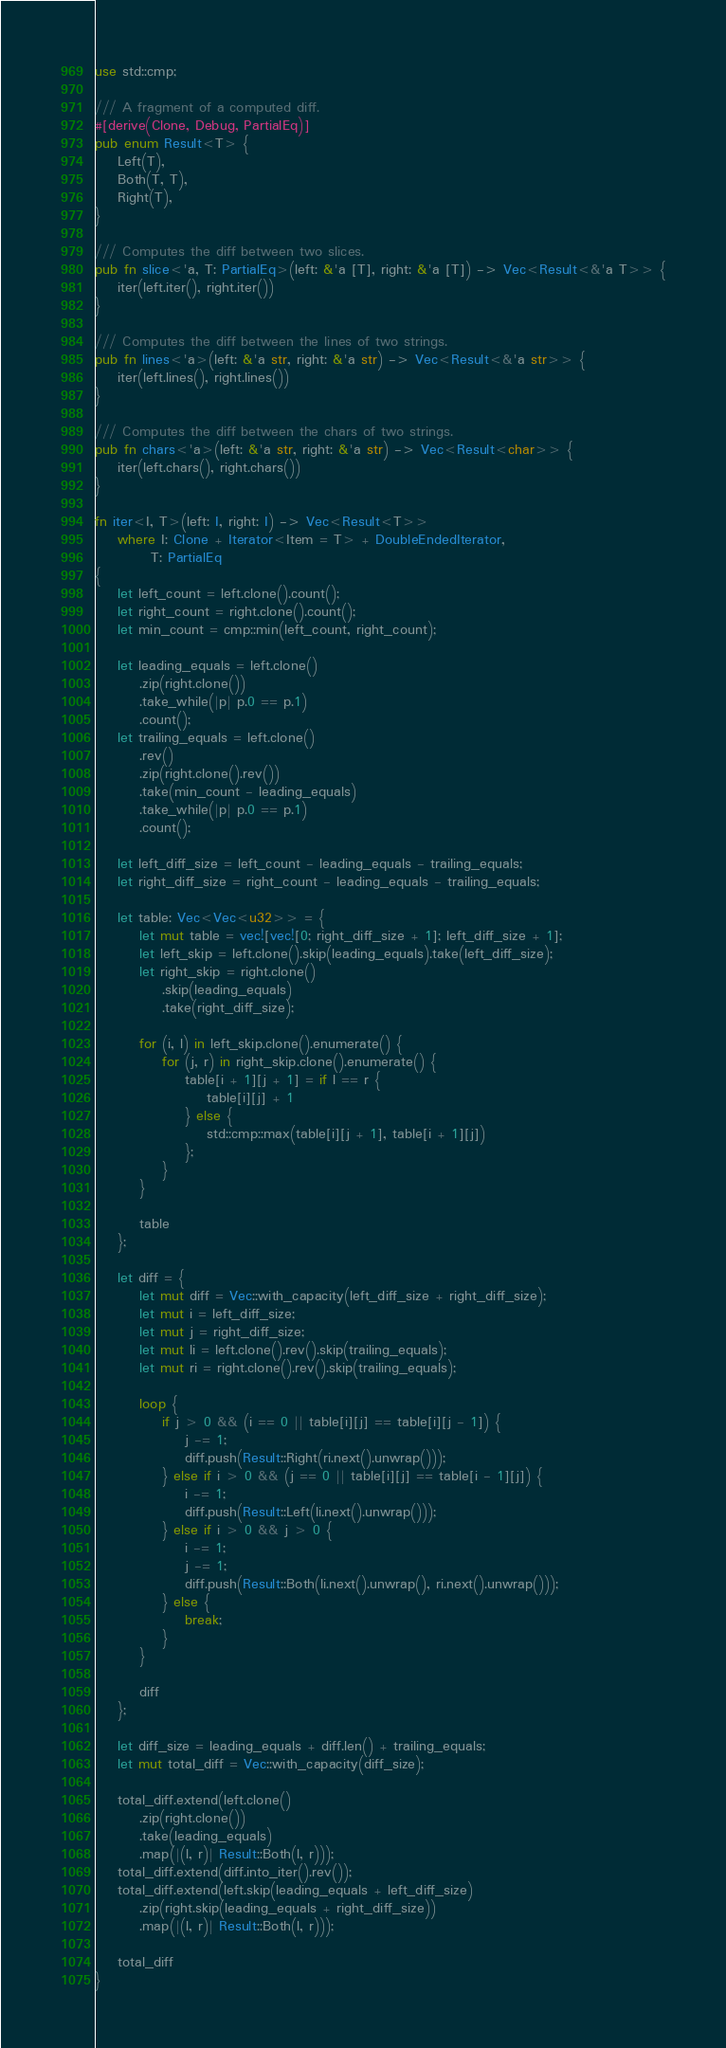Convert code to text. <code><loc_0><loc_0><loc_500><loc_500><_Rust_>use std::cmp;

/// A fragment of a computed diff.
#[derive(Clone, Debug, PartialEq)]
pub enum Result<T> {
    Left(T),
    Both(T, T),
    Right(T),
}

/// Computes the diff between two slices.
pub fn slice<'a, T: PartialEq>(left: &'a [T], right: &'a [T]) -> Vec<Result<&'a T>> {
    iter(left.iter(), right.iter())
}

/// Computes the diff between the lines of two strings.
pub fn lines<'a>(left: &'a str, right: &'a str) -> Vec<Result<&'a str>> {
    iter(left.lines(), right.lines())
}

/// Computes the diff between the chars of two strings.
pub fn chars<'a>(left: &'a str, right: &'a str) -> Vec<Result<char>> {
    iter(left.chars(), right.chars())
}

fn iter<I, T>(left: I, right: I) -> Vec<Result<T>>
    where I: Clone + Iterator<Item = T> + DoubleEndedIterator,
          T: PartialEq
{
    let left_count = left.clone().count();
    let right_count = right.clone().count();
    let min_count = cmp::min(left_count, right_count);

    let leading_equals = left.clone()
        .zip(right.clone())
        .take_while(|p| p.0 == p.1)
        .count();
    let trailing_equals = left.clone()
        .rev()
        .zip(right.clone().rev())
        .take(min_count - leading_equals)
        .take_while(|p| p.0 == p.1)
        .count();

    let left_diff_size = left_count - leading_equals - trailing_equals;
    let right_diff_size = right_count - leading_equals - trailing_equals;

    let table: Vec<Vec<u32>> = {
        let mut table = vec![vec![0; right_diff_size + 1]; left_diff_size + 1];
        let left_skip = left.clone().skip(leading_equals).take(left_diff_size);
        let right_skip = right.clone()
            .skip(leading_equals)
            .take(right_diff_size);

        for (i, l) in left_skip.clone().enumerate() {
            for (j, r) in right_skip.clone().enumerate() {
                table[i + 1][j + 1] = if l == r {
                    table[i][j] + 1
                } else {
                    std::cmp::max(table[i][j + 1], table[i + 1][j])
                };
            }
        }

        table
    };

    let diff = {
        let mut diff = Vec::with_capacity(left_diff_size + right_diff_size);
        let mut i = left_diff_size;
        let mut j = right_diff_size;
        let mut li = left.clone().rev().skip(trailing_equals);
        let mut ri = right.clone().rev().skip(trailing_equals);

        loop {
            if j > 0 && (i == 0 || table[i][j] == table[i][j - 1]) {
                j -= 1;
                diff.push(Result::Right(ri.next().unwrap()));
            } else if i > 0 && (j == 0 || table[i][j] == table[i - 1][j]) {
                i -= 1;
                diff.push(Result::Left(li.next().unwrap()));
            } else if i > 0 && j > 0 {
                i -= 1;
                j -= 1;
                diff.push(Result::Both(li.next().unwrap(), ri.next().unwrap()));
            } else {
                break;
            }
        }

        diff
    };

    let diff_size = leading_equals + diff.len() + trailing_equals;
    let mut total_diff = Vec::with_capacity(diff_size);

    total_diff.extend(left.clone()
        .zip(right.clone())
        .take(leading_equals)
        .map(|(l, r)| Result::Both(l, r)));
    total_diff.extend(diff.into_iter().rev());
    total_diff.extend(left.skip(leading_equals + left_diff_size)
        .zip(right.skip(leading_equals + right_diff_size))
        .map(|(l, r)| Result::Both(l, r)));

    total_diff
}
</code> 